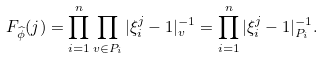Convert formula to latex. <formula><loc_0><loc_0><loc_500><loc_500>F _ { \widehat { \phi } } ( j ) = \prod _ { i = 1 } ^ { n } \prod _ { v \in P _ { i } } | \xi _ { i } ^ { j } - 1 | _ { v } ^ { - 1 } = \prod _ { i = 1 } ^ { n } | \xi _ { i } ^ { j } - 1 | _ { P _ { i } } ^ { - 1 } .</formula> 